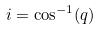Convert formula to latex. <formula><loc_0><loc_0><loc_500><loc_500>i = \cos ^ { - 1 } ( q )</formula> 